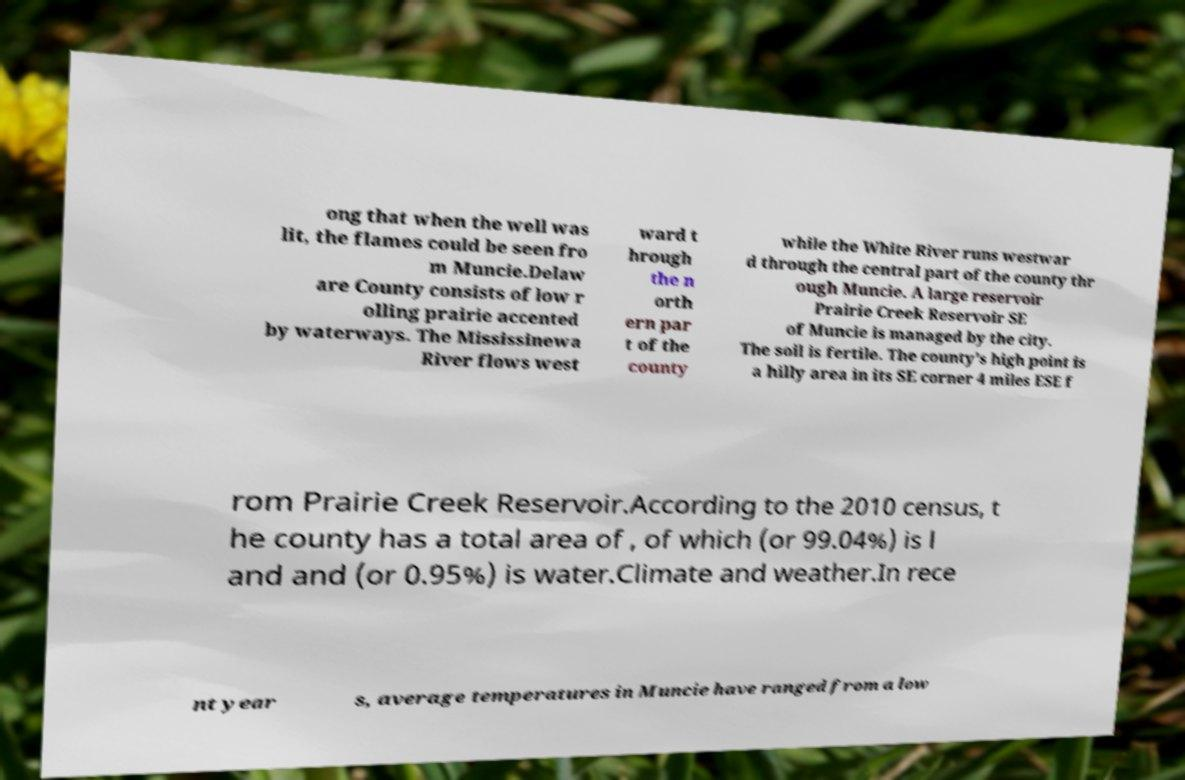What messages or text are displayed in this image? I need them in a readable, typed format. ong that when the well was lit, the flames could be seen fro m Muncie.Delaw are County consists of low r olling prairie accented by waterways. The Mississinewa River flows west ward t hrough the n orth ern par t of the county while the White River runs westwar d through the central part of the county thr ough Muncie. A large reservoir Prairie Creek Reservoir SE of Muncie is managed by the city. The soil is fertile. The county's high point is a hilly area in its SE corner 4 miles ESE f rom Prairie Creek Reservoir.According to the 2010 census, t he county has a total area of , of which (or 99.04%) is l and and (or 0.95%) is water.Climate and weather.In rece nt year s, average temperatures in Muncie have ranged from a low 